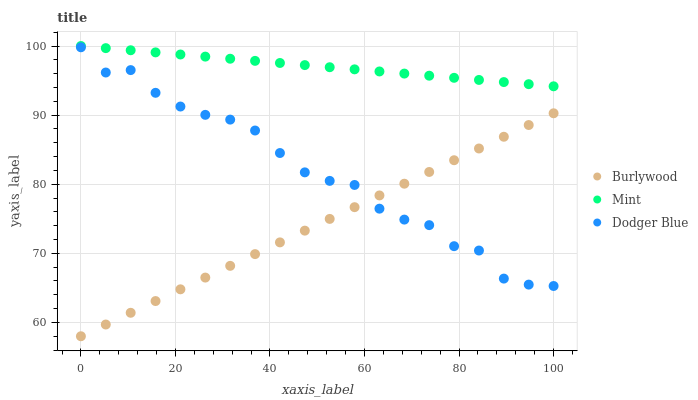Does Burlywood have the minimum area under the curve?
Answer yes or no. Yes. Does Mint have the maximum area under the curve?
Answer yes or no. Yes. Does Dodger Blue have the minimum area under the curve?
Answer yes or no. No. Does Dodger Blue have the maximum area under the curve?
Answer yes or no. No. Is Mint the smoothest?
Answer yes or no. Yes. Is Dodger Blue the roughest?
Answer yes or no. Yes. Is Dodger Blue the smoothest?
Answer yes or no. No. Is Mint the roughest?
Answer yes or no. No. Does Burlywood have the lowest value?
Answer yes or no. Yes. Does Dodger Blue have the lowest value?
Answer yes or no. No. Does Mint have the highest value?
Answer yes or no. Yes. Does Dodger Blue have the highest value?
Answer yes or no. No. Is Burlywood less than Mint?
Answer yes or no. Yes. Is Mint greater than Dodger Blue?
Answer yes or no. Yes. Does Burlywood intersect Dodger Blue?
Answer yes or no. Yes. Is Burlywood less than Dodger Blue?
Answer yes or no. No. Is Burlywood greater than Dodger Blue?
Answer yes or no. No. Does Burlywood intersect Mint?
Answer yes or no. No. 